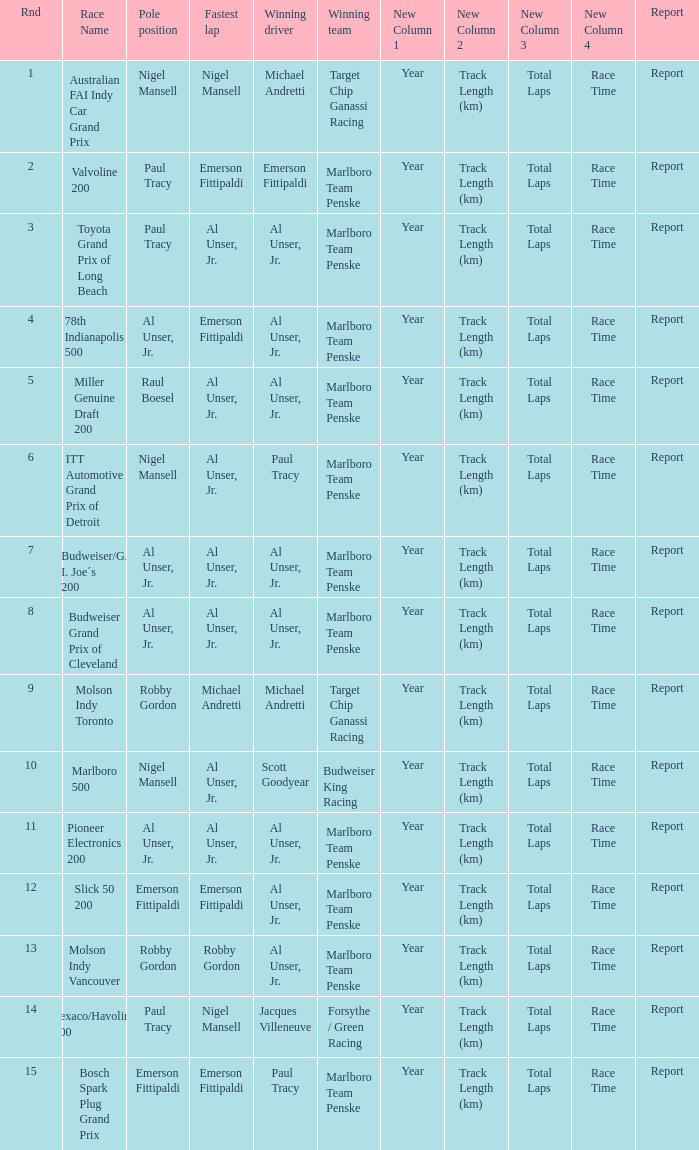Who was on the pole position in the Texaco/Havoline 200 race? Paul Tracy. 